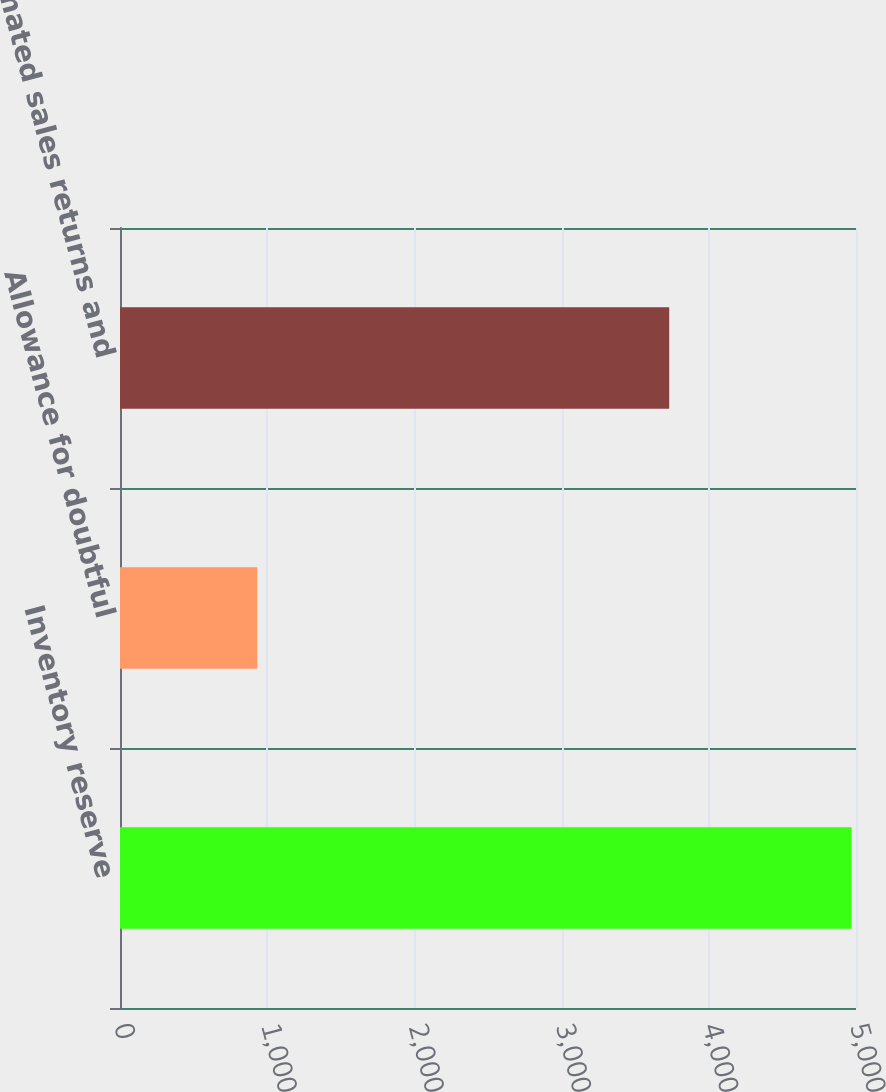<chart> <loc_0><loc_0><loc_500><loc_500><bar_chart><fcel>Inventory reserve<fcel>Allowance for doubtful<fcel>Estimated sales returns and<nl><fcel>4970<fcel>933<fcel>3731<nl></chart> 